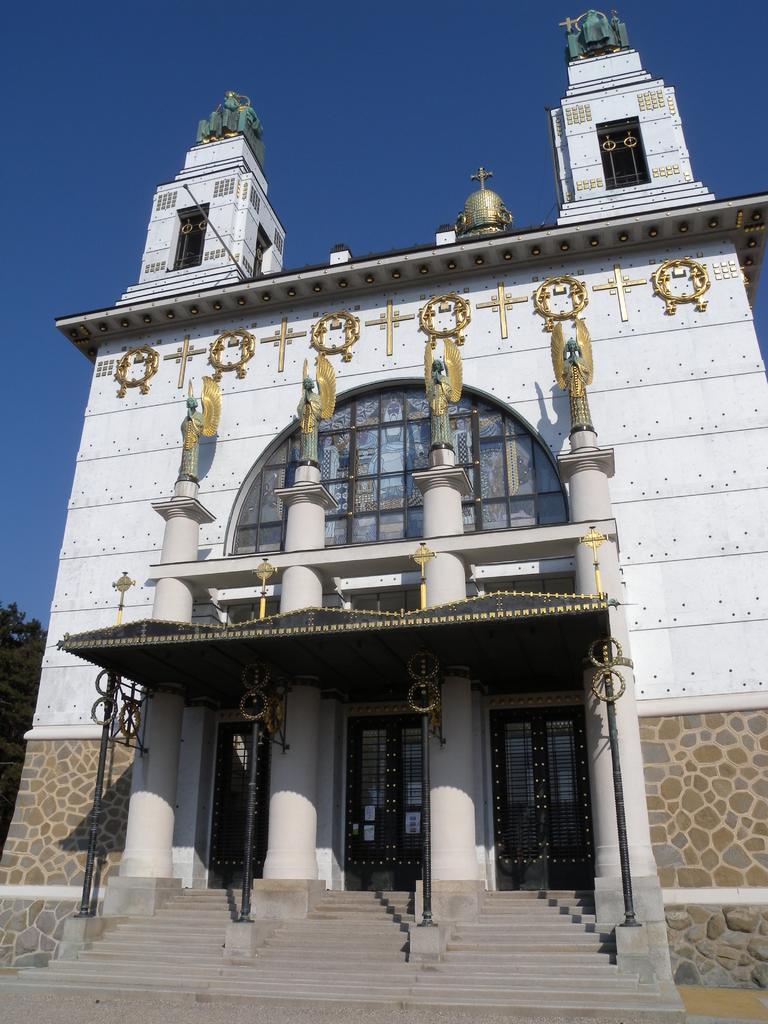Could you give a brief overview of what you see in this image? In this image in the center there is a building and in front of the building there is a tent, there are poles. On the left side of the building there is a tree. 